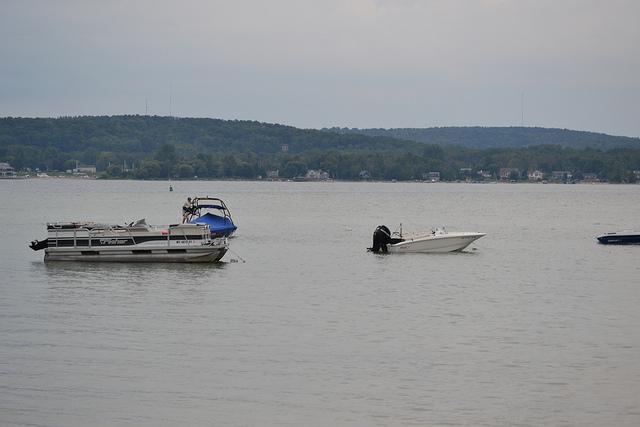Could this be a lake?
Answer briefly. Yes. What kind of boat is this?
Keep it brief. Motor. What does the boat say?
Short answer required. Boat. Does this look like an expensive new boat?
Concise answer only. No. Is the boat moving?
Write a very short answer. No. What is on the water?
Be succinct. Boats. Are there any sailboats in the area?
Short answer required. No. Are there people on the boats?
Answer briefly. Yes. Do these boats have motors?
Write a very short answer. Yes. How many boats are on the water?
Be succinct. 4. What color is the boat?
Be succinct. White. How many boats are there?
Concise answer only. 4. Is there a person on the boat?
Answer briefly. Yes. How many boats are in the water?
Quick response, please. 4. Is the weather nice?
Be succinct. Yes. What is the deepest this pool gets in this picture?
Quick response, please. 30000'. How many people are in the boat?
Concise answer only. 1. How many windmills are in this picture?
Answer briefly. 0. Can you see people in the boats?
Write a very short answer. Yes. Are the boats in the water?
Quick response, please. Yes. What kind of boats are these?
Answer briefly. 3. How many boats on the water?
Be succinct. 4. 